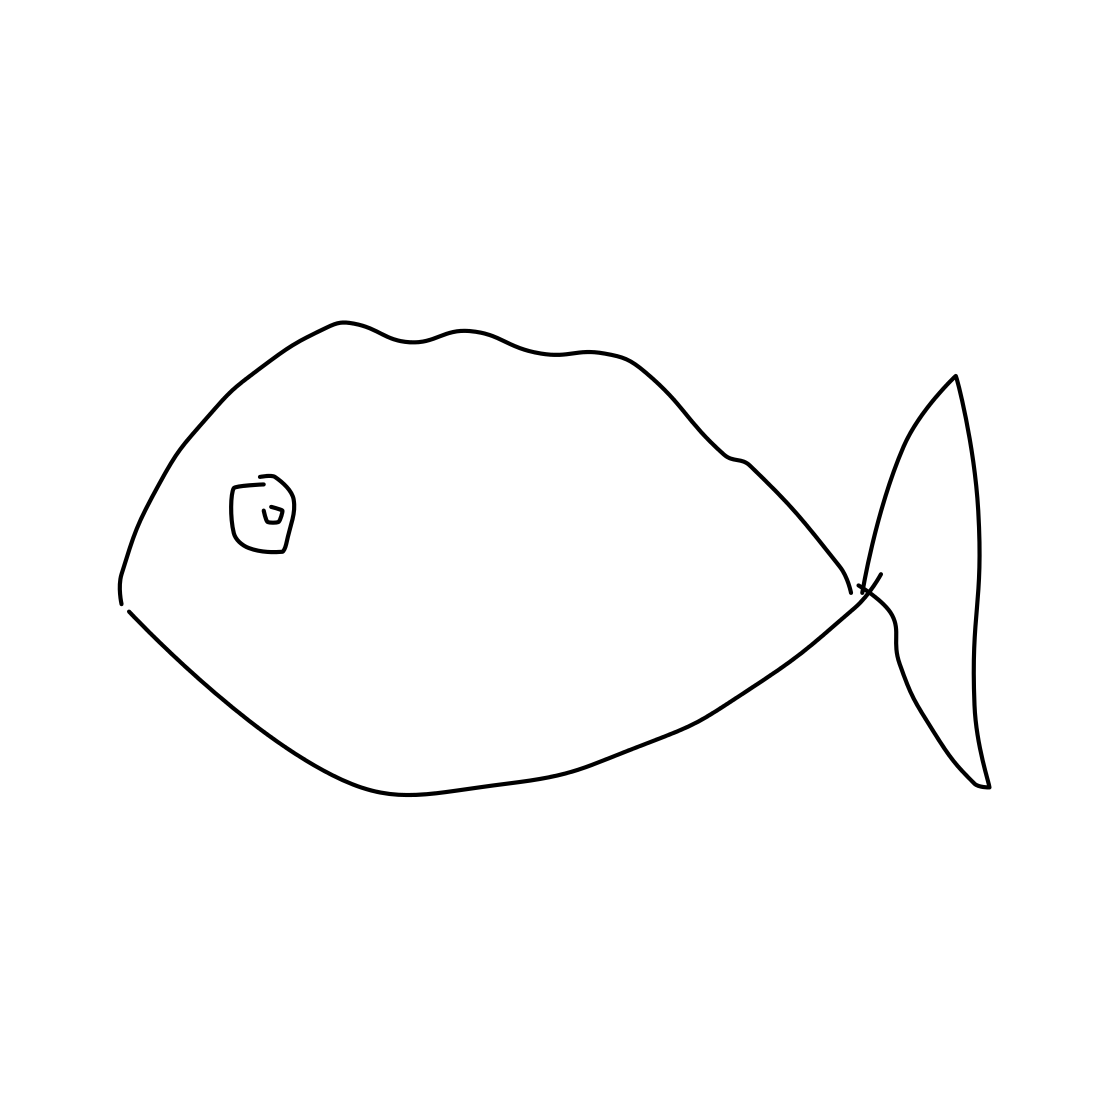Is there a sketchy ant in the picture? No 